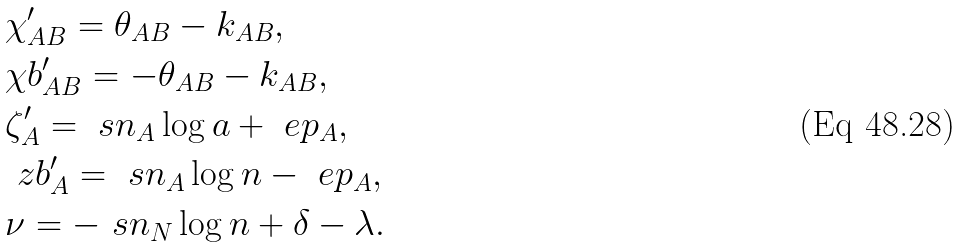<formula> <loc_0><loc_0><loc_500><loc_500>& \chi ^ { \prime } _ { A B } = \theta _ { A B } - k _ { A B } , \\ & \chi b ^ { \prime } _ { A B } = - \theta _ { A B } - k _ { A B } , \\ & \zeta ^ { \prime } _ { A } = \ s n _ { A } \log a + \ e p _ { A } , \\ & \ z b ^ { \prime } _ { A } = \ s n _ { A } \log n - \ e p _ { A } , \\ & \nu = - \ s n _ { N } \log n + \delta - \lambda .</formula> 